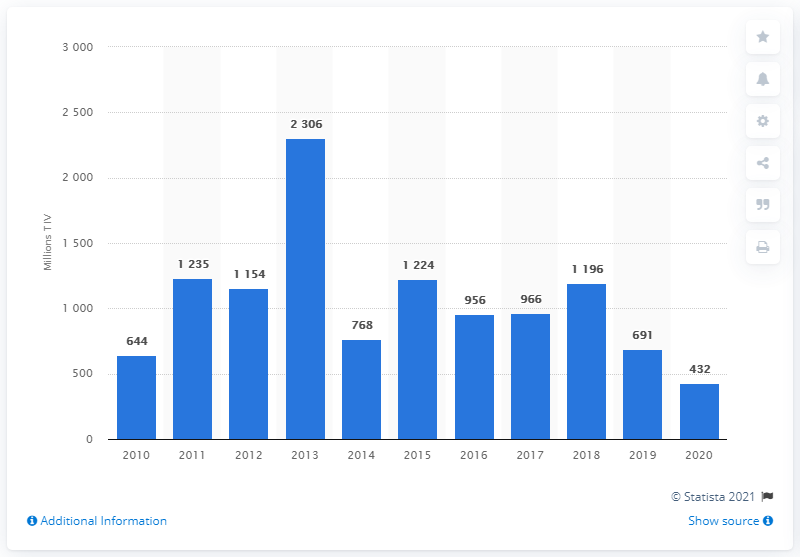What was the value of arms imports to the United Arab Emirates in 2020? In 2020, the United Arab Emirates' arms imports were valued at 432 million USD, as depicted in the bar graph. This represents a decrease from previous years, reflecting changes in the country's defense procurement strategy or adjusting to global events that year. 